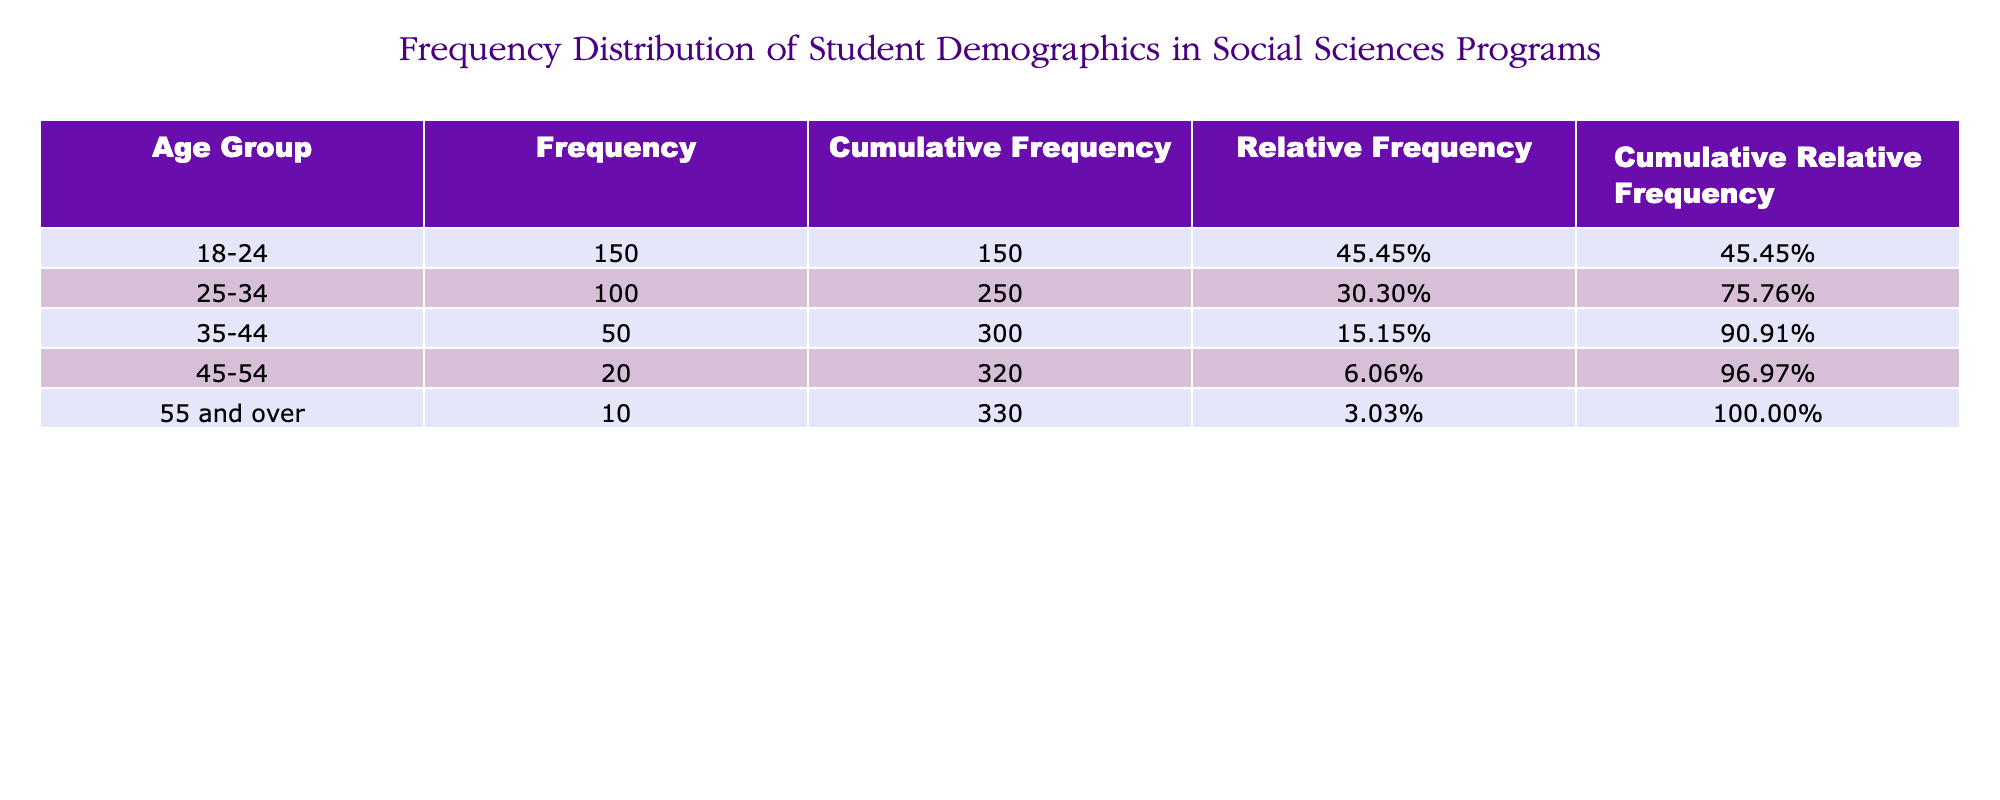What is the frequency of students in the age group 25-34? From the table, you can find the frequency of students in the age group 25-34 directly listed under the "Frequency" column. It shows 100 students.
Answer: 100 What is the total number of students across all age groups? To find the total number of students, sum up the frequencies of each age group: 150 + 100 + 50 + 20 + 10 = 330.
Answer: 330 What is the relative frequency of the age group 18-24? The relative frequency is calculated by dividing the number of students in the age group 18-24 by the total number of students. From the table, the calculation is 150 / 330, which equals approximately 0.454545 or 45.45%.
Answer: 45.45% Is the number of students in the age group 45-54 greater than those in the age group 35-44? By comparing the frequencies listed in the table, the number of students in age group 45-54 is 20, while in the age group 35-44, it is 50. Since 20 is less than 50, the statement is false.
Answer: No What is the cumulative frequency of the age group 35-44? The cumulative frequency for the age group 35-44 includes all students from the groups below it: 150 (18-24) + 100 (25-34) + 50 (35-44) = 300. Therefore, the cumulative frequency for this group is 300.
Answer: 300 What is the cumulative relative frequency for the age group 25-34? The cumulative relative frequency is found by adding the relative frequencies of the age groups up to and including 25-34. The relative frequency for 18-24 is approximately 0.454545, and for 25-34, it is approximately 0.303030. So, 0.454545 + 0.303030 = 0.757575, or 75.76%.
Answer: 75.76% Is the relative frequency of students 55 and over greater than 5%? To determine this, the relative frequency of the age group 55 and over is calculated as 10 (their number) divided by 330 (total students), which gives approximately 0.030303 or 3.03%. Since 3.03% is less than 5%, the statement is false.
Answer: No What age group has the least number of students, and how many are there? Looking through the table, the age group with the least number of students is 55 and over, with only 10 students in that group.
Answer: 55 and over, 10 